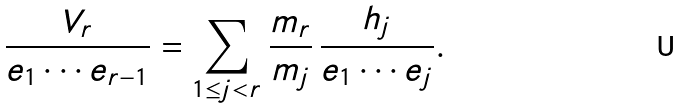Convert formula to latex. <formula><loc_0><loc_0><loc_500><loc_500>\frac { V _ { r } } { e _ { 1 } \cdots e _ { r - 1 } } = \sum _ { 1 \leq j < r } \frac { m _ { r } } { m _ { j } } \, \frac { h _ { j } } { e _ { 1 } \cdots e _ { j } } .</formula> 